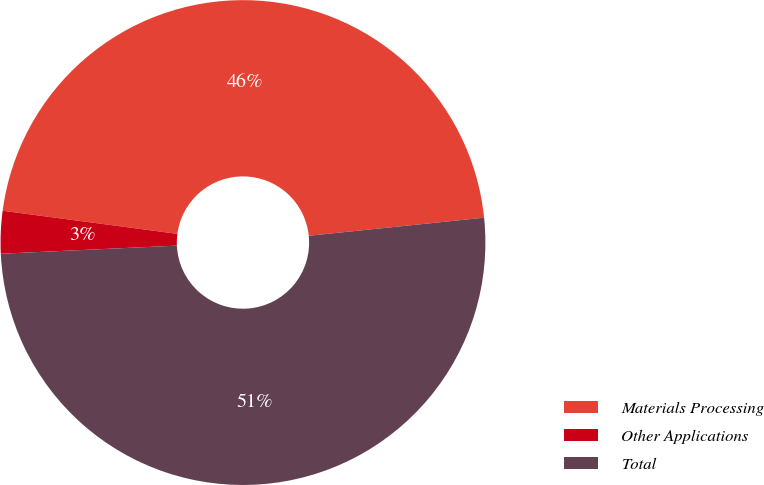<chart> <loc_0><loc_0><loc_500><loc_500><pie_chart><fcel>Materials Processing<fcel>Other Applications<fcel>Total<nl><fcel>46.27%<fcel>2.83%<fcel>50.9%<nl></chart> 